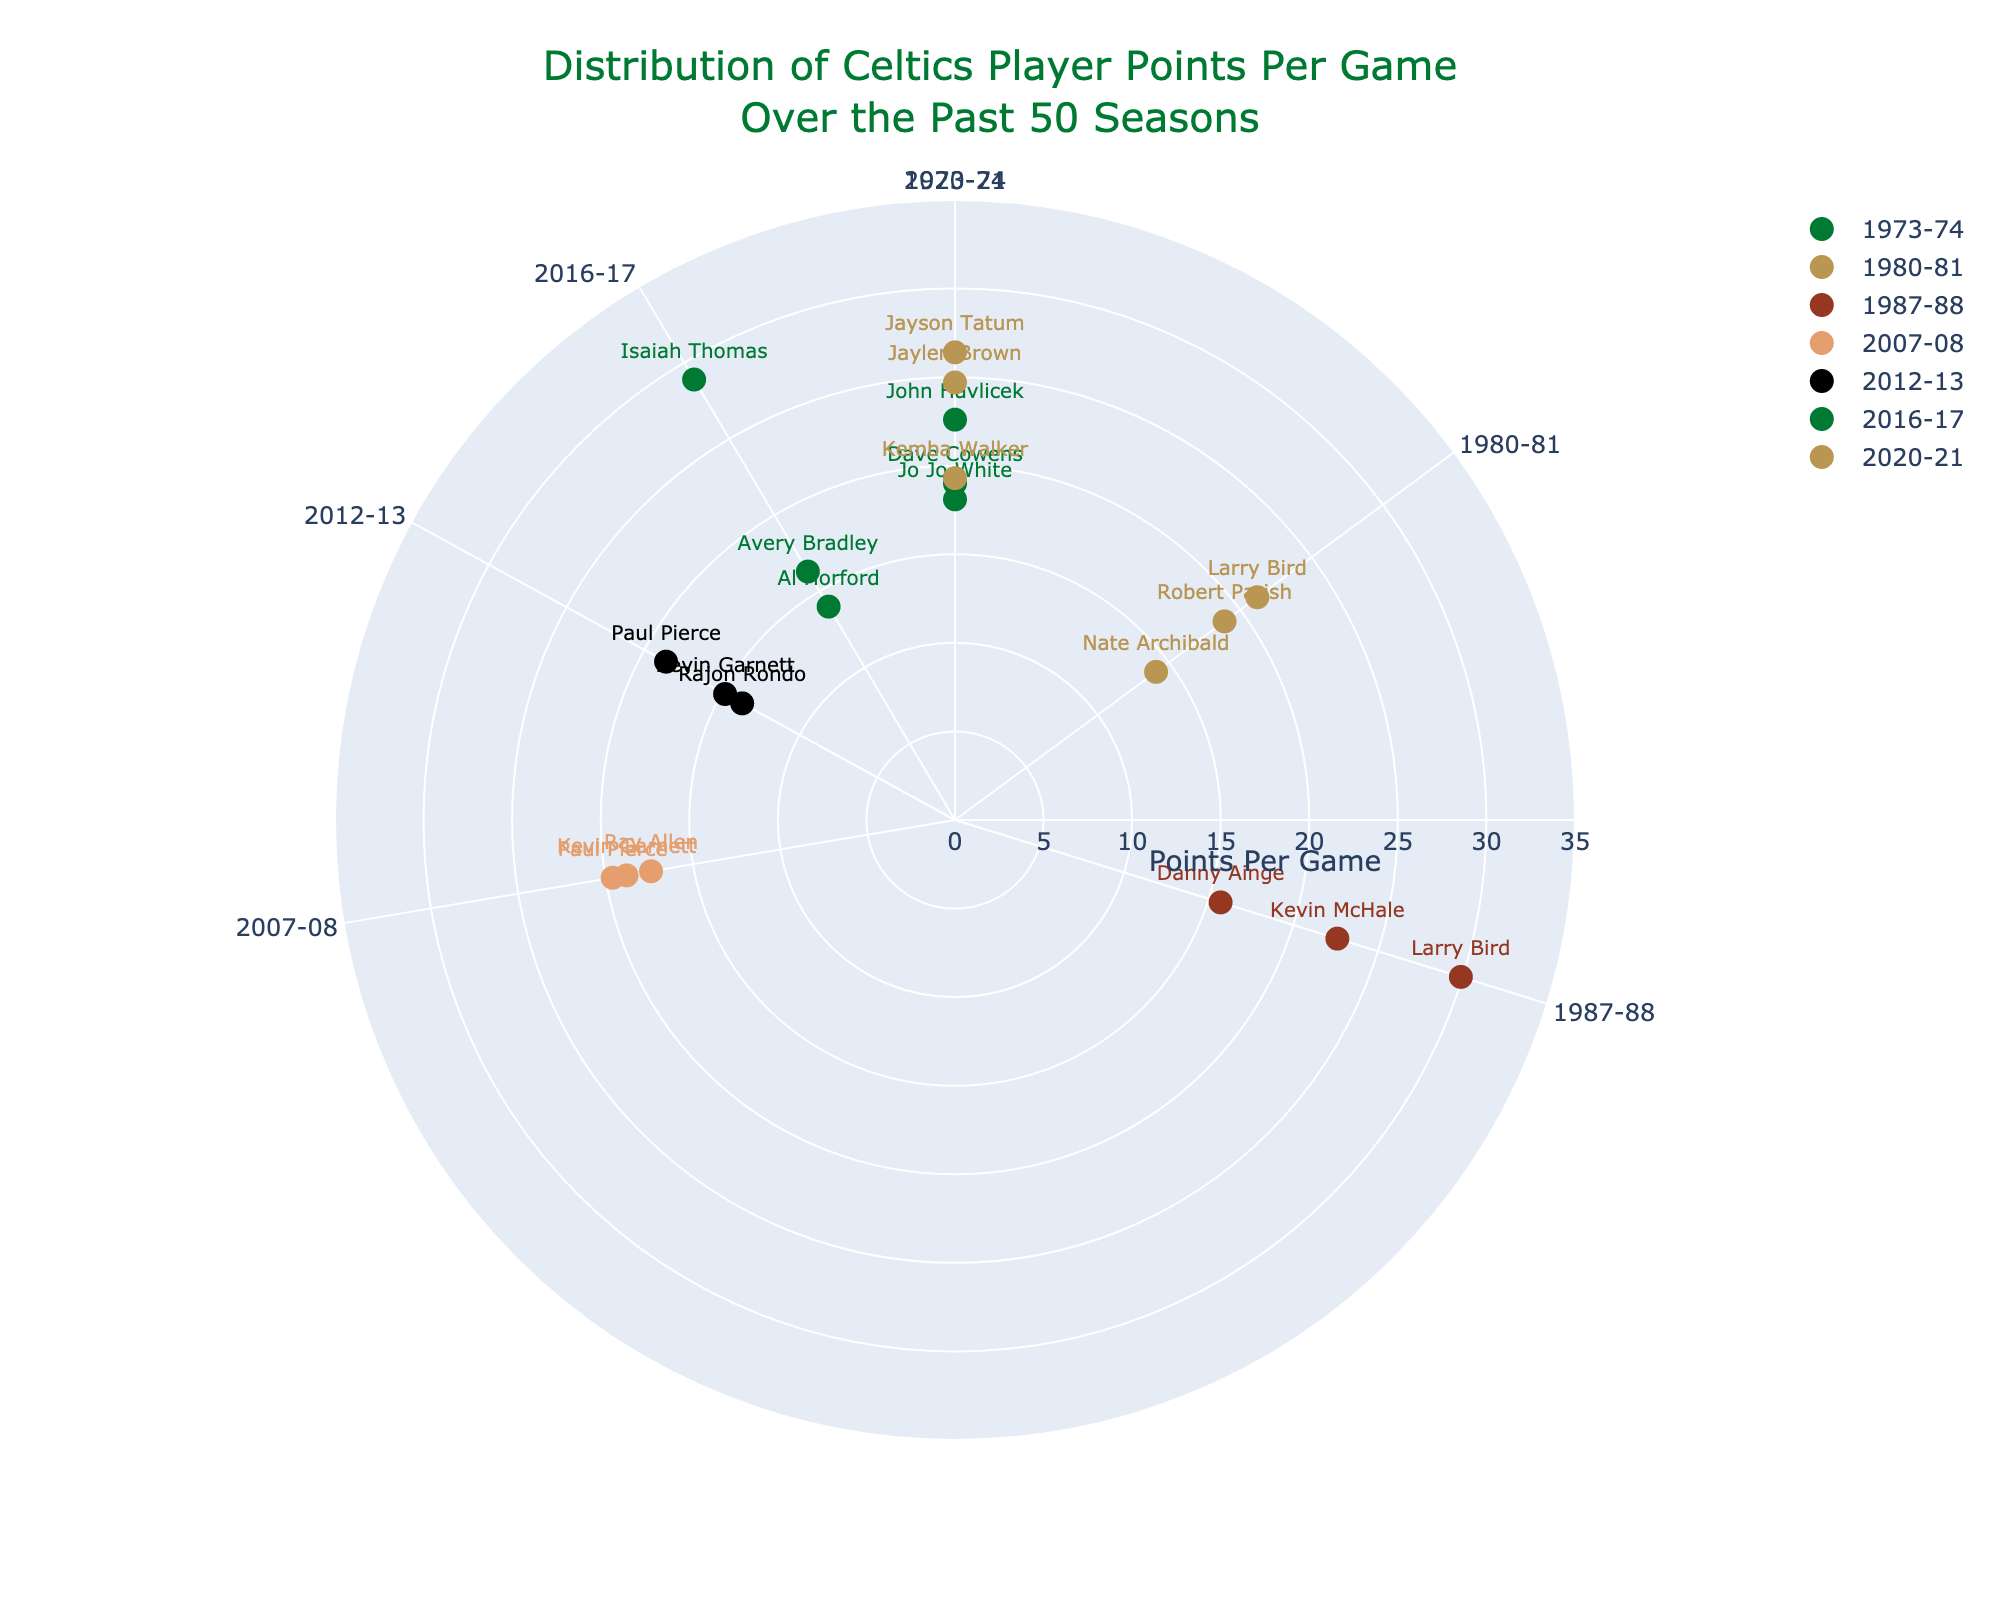what is the title of the chart? The title of the chart is typically placed at the top center of the figure. The title in this case would be "Distribution of Celtics Player Points Per Game Over the Past 50 Seasons".
Answer: "Distribution of Celtics Player Points Per Game Over the Past 50 Seasons" How many players are shown for the 2020-21 season? To answer this, look at the radial points labeled "2020-21" marked by their distinct colors, and count the number of players listed. Here, there are three players: Jayson Tatum, Jaylen Brown, and Kemba Walker.
Answer: 3 Which player has the highest points per game in the 2016-17 season and what is the value? Locate the radial points labeled "2016-17". Compare the 'r' values to find that Isaiah Thomas has the highest points per game for that season with 28.9 PPG.
Answer: Isaiah Thomas, 28.9 How many seasons are represented on the chart? Count the number of unique angular values which represent different seasons on the polar scatter chart. Here, they are 1973-74, 1980-81, 1987-88, 2007-08, 2012-13, 2016-17, and 2020-21.
Answer: 7 Who scored more points per game in the 1987-88 season, Larry Bird or Kevin McHale? Compare the 'r' values (Points Per Game) for Larry Bird and Kevin McHale in the 1987-88 season. Larry Bird's PPG is 29.9, and Kevin McHale's PPG is 22.6, so Larry Bird scored more points.
Answer: Larry Bird What is the range of points per game for all the players in the 1980-81 season? Locate all the points for the 1980-81 season and find their 'r' (Points Per Game). The values are 21.2, 18.9, and 14.1. The range is then calculated as the highest value minus the lowest value: 21.2 - 14.1.
Answer: 7.1 What is the average points per game for the players in the 2007-08 season? Identify the 'r' (Points Per Game) values for all players in the 2007-08 season: Paul Pierce (19.6), Kevin Garnett (18.8), and Ray Allen (17.4). Sum these up and divide by the number of players to get the average: (19.6 + 18.8 + 17.4) / 3.
Answer: 18.6 Which season has the most player data points represented? Count the number of data points (players) for each season. Compare these counts to find that the 2020-21 and 1987-88 seasons both have three data points.
Answer: 2020-21 and 1987-88 Who has the highest single points per game value across all the seasons represented? Identify the highest 'r' (Points Per Game) value on the polar scatter chart. Larry Bird in 1987-88 with 29.9 PPG is the highest of all the players shown.
Answer: Larry Bird, 29.9 